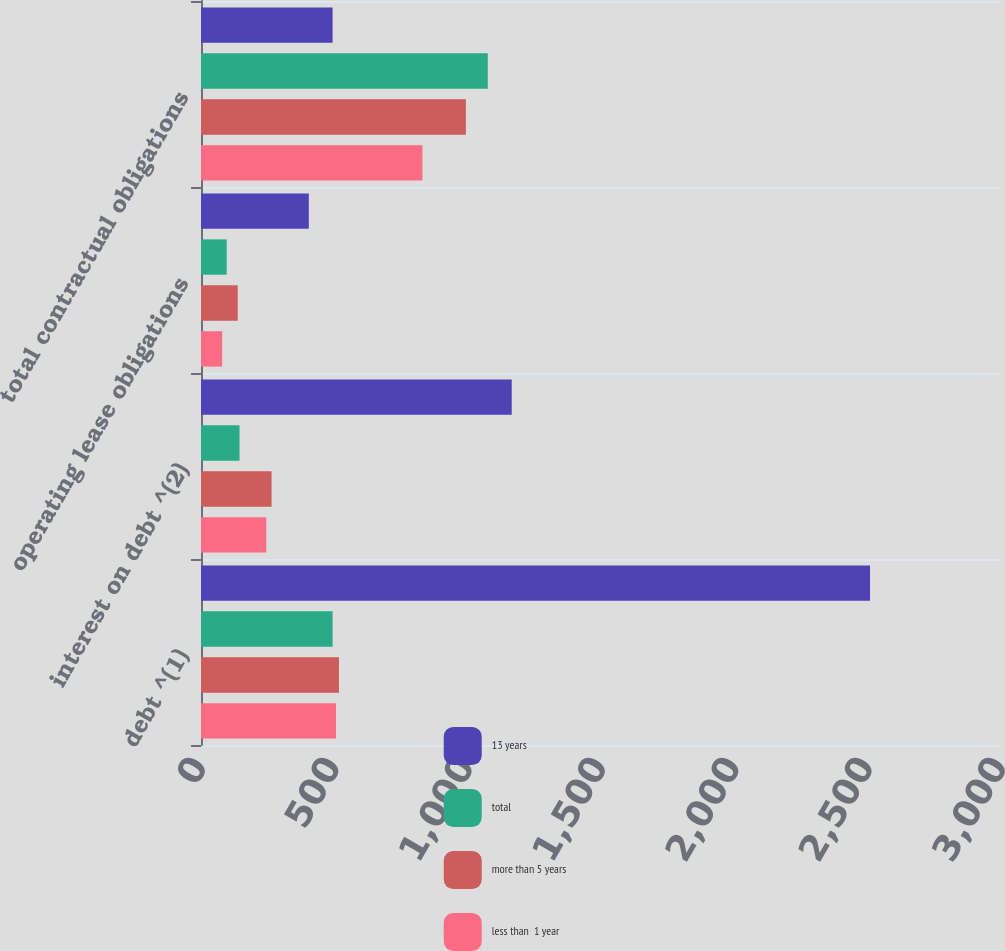Convert chart. <chart><loc_0><loc_0><loc_500><loc_500><stacked_bar_chart><ecel><fcel>debt ^(1)<fcel>interest on debt ^(2)<fcel>operating lease obligations<fcel>total contractual obligations<nl><fcel>13 years<fcel>2508.8<fcel>1165.2<fcel>404.3<fcel>493.5<nl><fcel>total<fcel>493.5<fcel>144.5<fcel>96.5<fcel>1075.4<nl><fcel>more than 5 years<fcel>517.3<fcel>264.6<fcel>137.7<fcel>993.3<nl><fcel>less than  1 year<fcel>506.2<fcel>244.8<fcel>79.4<fcel>830.4<nl></chart> 